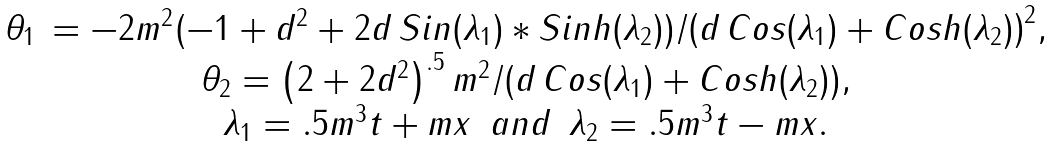Convert formula to latex. <formula><loc_0><loc_0><loc_500><loc_500>\begin{array} { c c } \theta _ { 1 } \, = { - 2 m ^ { 2 } ( - 1 + d ^ { 2 } + 2 d \, S i n ( \lambda _ { 1 } ) * S i n h ( \lambda _ { 2 } ) ) } / { \left ( d \, C o s ( \lambda _ { 1 } ) + C o s h ( \lambda _ { 2 } ) \right ) ^ { 2 } } , \\ \theta _ { 2 } = { \left ( 2 + 2 d ^ { 2 } \right ) ^ { . 5 } m ^ { 2 } } / { \left ( d \, C o s ( \lambda _ { 1 } ) + C o s h ( \lambda _ { 2 } ) \right ) } , \\ \lambda _ { 1 } = . 5 m ^ { 3 } t + m x \, \ a n d \, \ \lambda _ { 2 } = . 5 m ^ { 3 } t - m x . \end{array}</formula> 